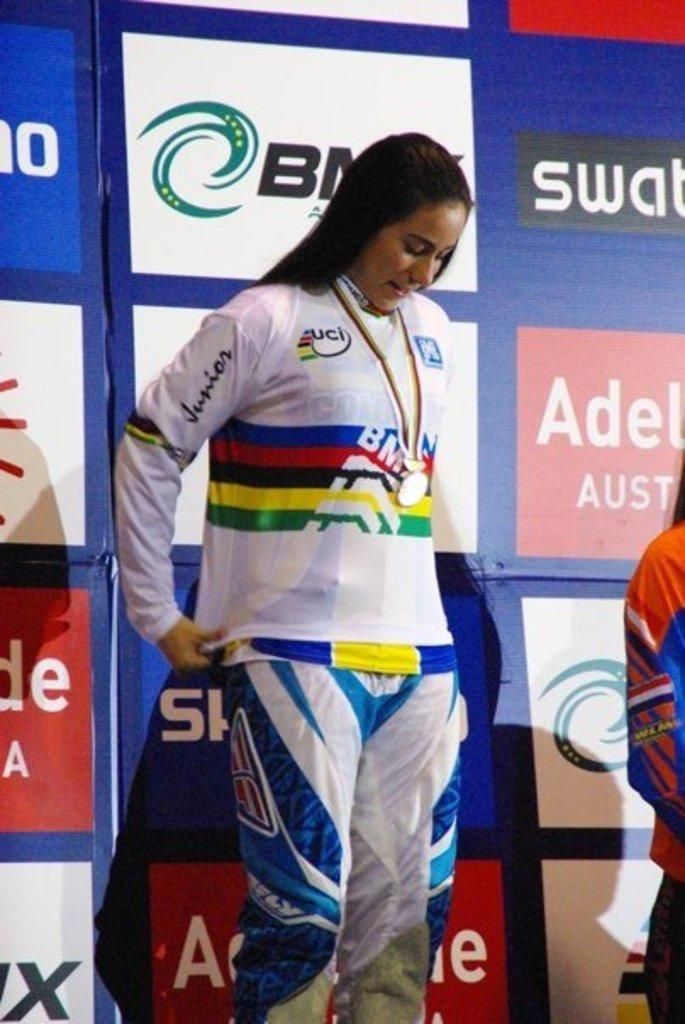<image>
Provide a brief description of the given image. A woman in BMX athletic attire is standing with a medal around her neck. 